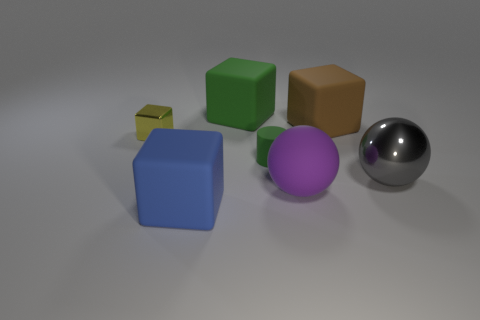Subtract all green rubber cubes. How many cubes are left? 3 Subtract all brown blocks. How many blocks are left? 3 Subtract all cylinders. How many objects are left? 6 Add 1 purple matte things. How many objects exist? 8 Subtract all red blocks. Subtract all cyan spheres. How many blocks are left? 4 Add 7 big rubber cubes. How many big rubber cubes exist? 10 Subtract 0 purple cubes. How many objects are left? 7 Subtract all tiny metallic balls. Subtract all green matte blocks. How many objects are left? 6 Add 3 small green things. How many small green things are left? 4 